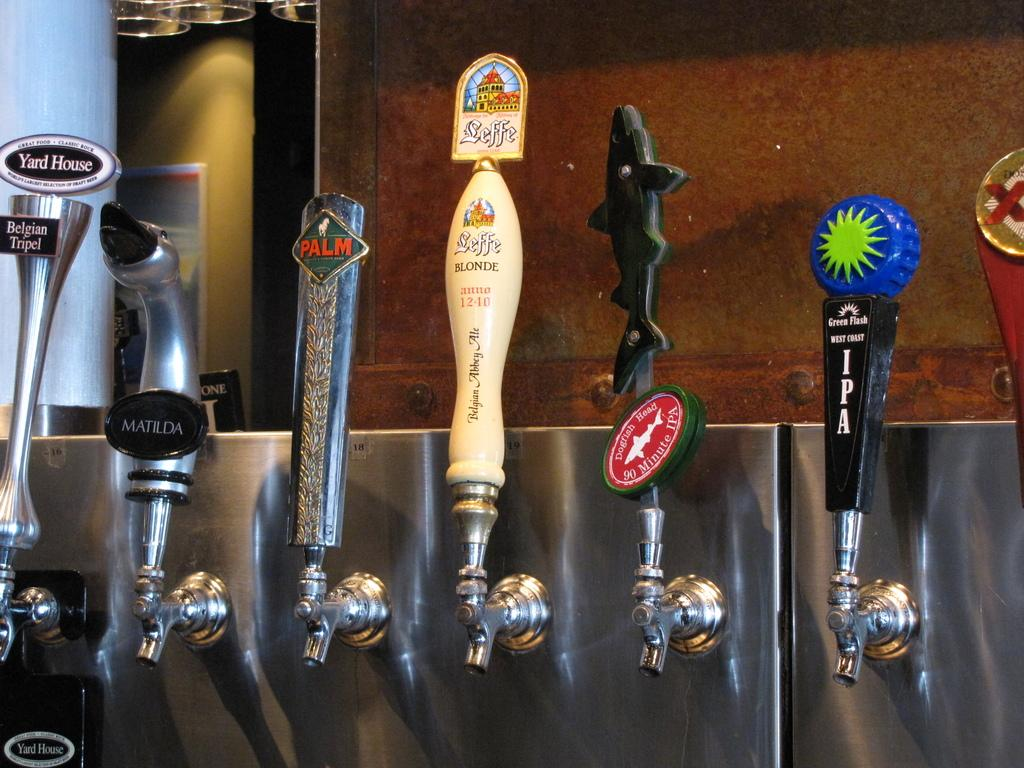What can be seen in the image related to water flow? There are different types of taps in the image. Can you describe the colors of the taps? The taps include black, blue, red, and cream colors. What is visible in the background of the image? There is a brown color wall in the background of the image. What type of impulse does the grandfather give to the coach in the image? There is no grandfather, coach, or impulse present in the image; it only features different types of taps. 